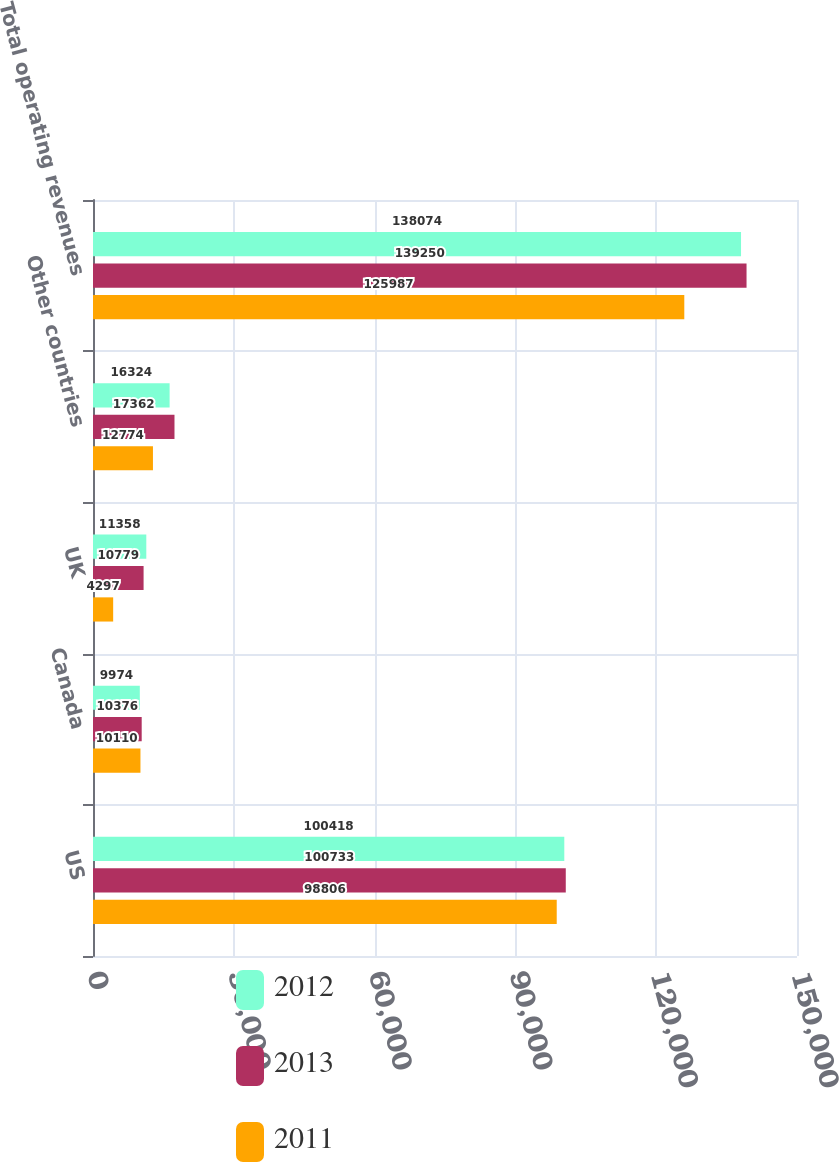<chart> <loc_0><loc_0><loc_500><loc_500><stacked_bar_chart><ecel><fcel>US<fcel>Canada<fcel>UK<fcel>Other countries<fcel>Total operating revenues<nl><fcel>2012<fcel>100418<fcel>9974<fcel>11358<fcel>16324<fcel>138074<nl><fcel>2013<fcel>100733<fcel>10376<fcel>10779<fcel>17362<fcel>139250<nl><fcel>2011<fcel>98806<fcel>10110<fcel>4297<fcel>12774<fcel>125987<nl></chart> 